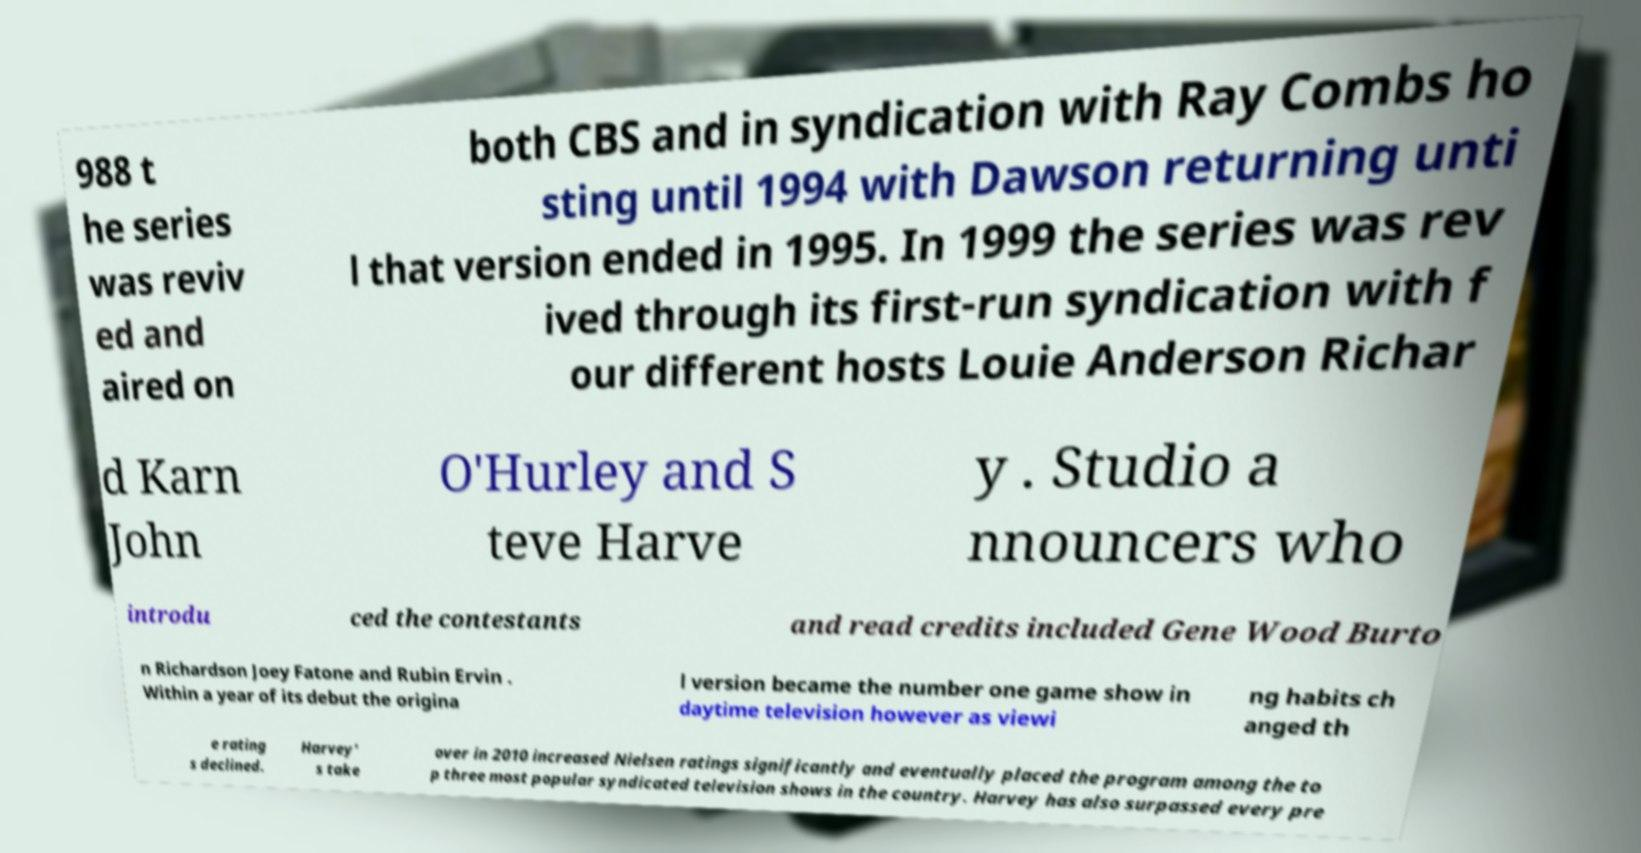Please read and relay the text visible in this image. What does it say? 988 t he series was reviv ed and aired on both CBS and in syndication with Ray Combs ho sting until 1994 with Dawson returning unti l that version ended in 1995. In 1999 the series was rev ived through its first-run syndication with f our different hosts Louie Anderson Richar d Karn John O'Hurley and S teve Harve y . Studio a nnouncers who introdu ced the contestants and read credits included Gene Wood Burto n Richardson Joey Fatone and Rubin Ervin . Within a year of its debut the origina l version became the number one game show in daytime television however as viewi ng habits ch anged th e rating s declined. Harvey' s take over in 2010 increased Nielsen ratings significantly and eventually placed the program among the to p three most popular syndicated television shows in the country. Harvey has also surpassed every pre 